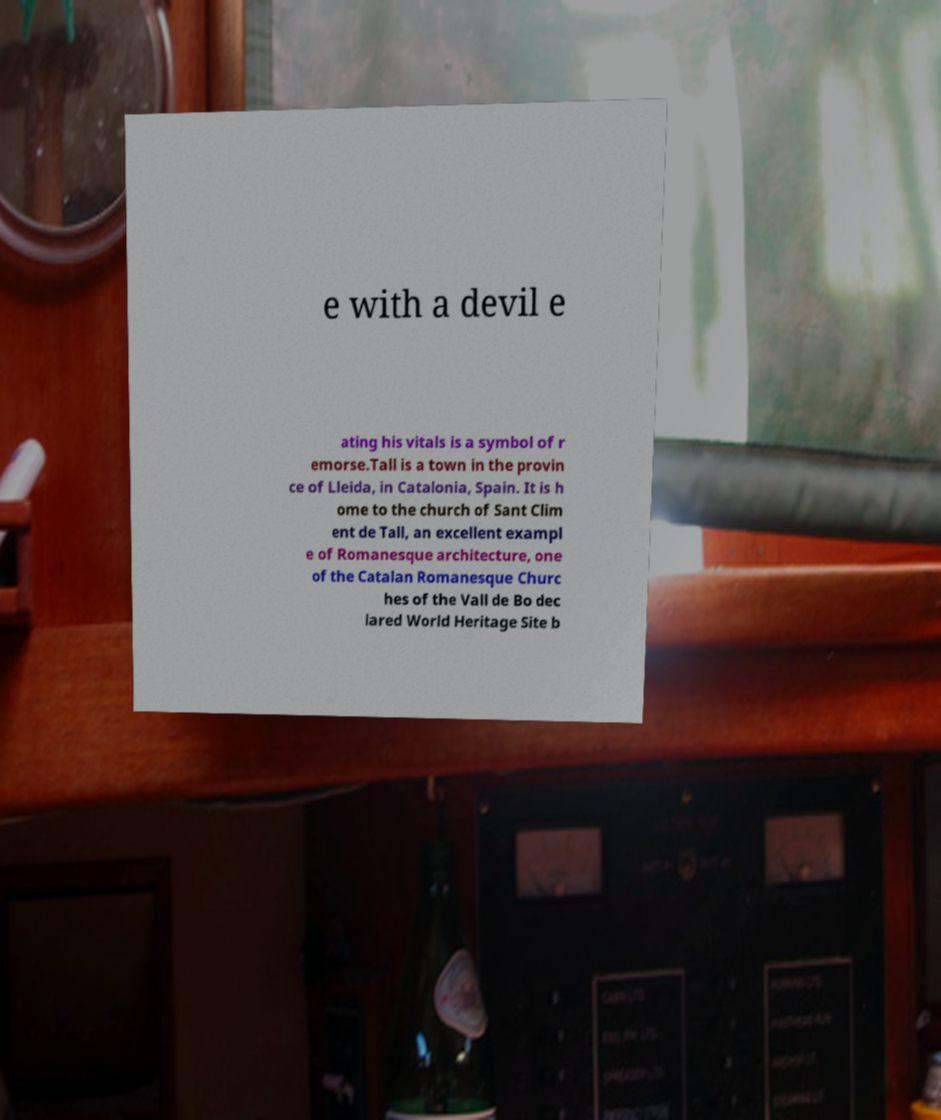Can you accurately transcribe the text from the provided image for me? e with a devil e ating his vitals is a symbol of r emorse.Tall is a town in the provin ce of Lleida, in Catalonia, Spain. It is h ome to the church of Sant Clim ent de Tall, an excellent exampl e of Romanesque architecture, one of the Catalan Romanesque Churc hes of the Vall de Bo dec lared World Heritage Site b 